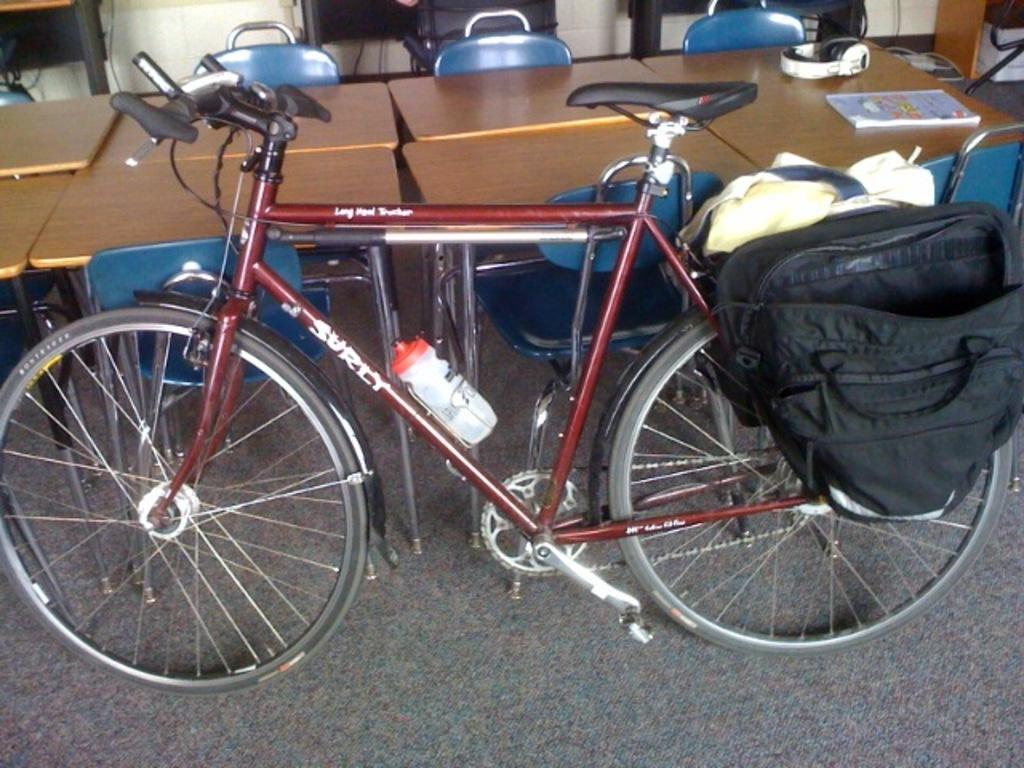Please provide a concise description of this image. In this picture we can see a bicycle and a backpack on it and in front of the bicycle there are some tables on which there is a head set and a book and some chairs behind the tables. 